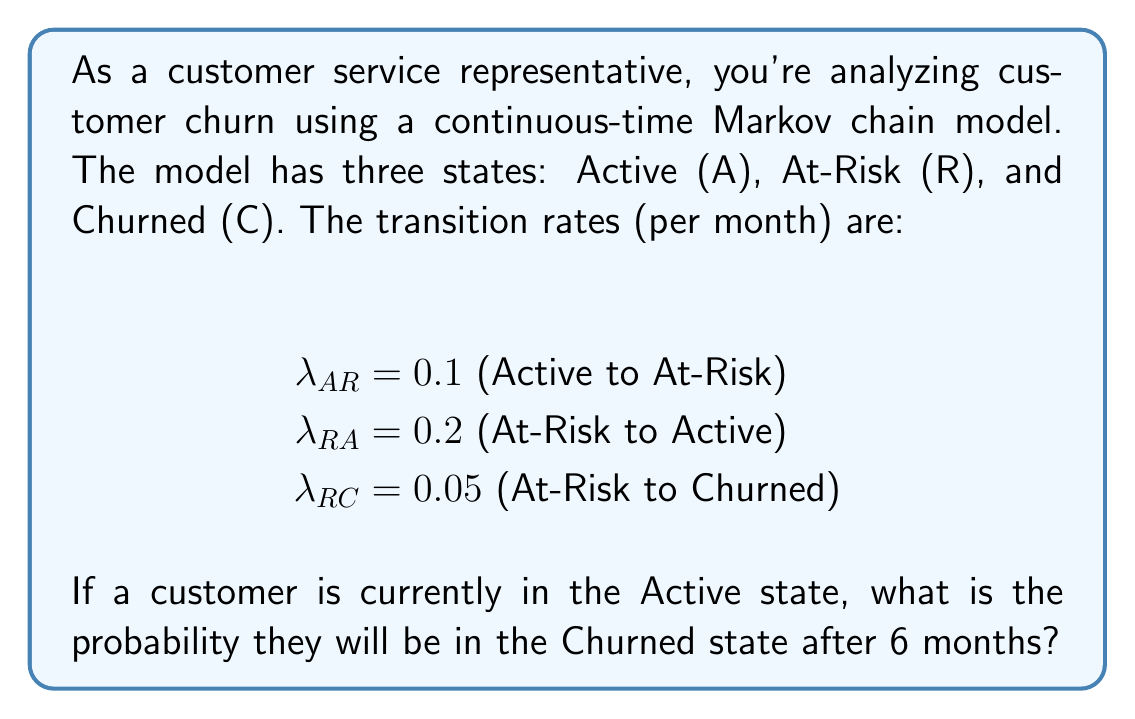Provide a solution to this math problem. To solve this problem, we'll use the continuous-time Markov chain model and follow these steps:

1) First, we need to set up the transition rate matrix Q:

   $$Q = \begin{bmatrix}
   -0.1 & 0.1 & 0 \\
   0.2 & -0.25 & 0.05 \\
   0 & 0 & 0
   \end{bmatrix}$$

2) The probability transition matrix after time t is given by:

   $$P(t) = e^{Qt}$$

3) We need to calculate $e^{Q6}$. This can be done using eigendecomposition:

   $$e^{Qt} = S e^{\Lambda t} S^{-1}$$

   where $\Lambda$ is a diagonal matrix of eigenvalues and S is a matrix of eigenvectors.

4) Calculate the eigenvalues and eigenvectors of Q:
   
   Eigenvalues: $\lambda_1 = 0, \lambda_2 = -0.0784, \lambda_3 = -0.2716$

5) The resulting probability transition matrix after 6 months is:

   $$P(6) \approx \begin{bmatrix}
   0.7897 & 0.1792 & 0.0311 \\
   0.7171 & 0.2274 & 0.0555 \\
   0 & 0 & 1
   \end{bmatrix}$$

6) The probability of transitioning from Active (state 1) to Churned (state 3) after 6 months is given by the element in the first row, third column of P(6).
Answer: 0.0311 or 3.11% 